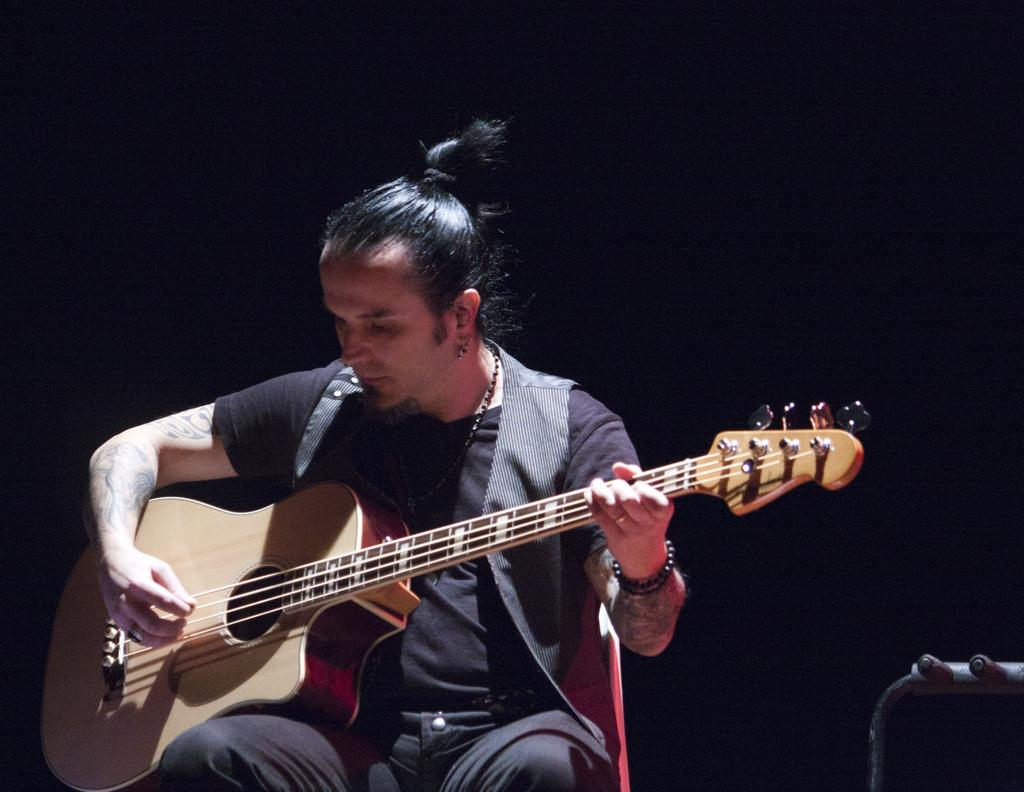What is the main subject of the image? The main subject of the image is a man. What is the man wearing in the image? The man is wearing a jacket in the image. What is the man holding in the image? The man is holding a guitar in the image. What is the man doing with the guitar? The man is playing the guitar in the image. What is the man sitting on in the image? The man is sitting on a chair in the image. How would you describe the background of the image? The background of the image is dark. What type of leather is visible on the man's wound in the image? There is no wound or leather present in the image; the man is playing a guitar while wearing a jacket. What does the image smell like? The image is a visual representation and does not have a smell. 